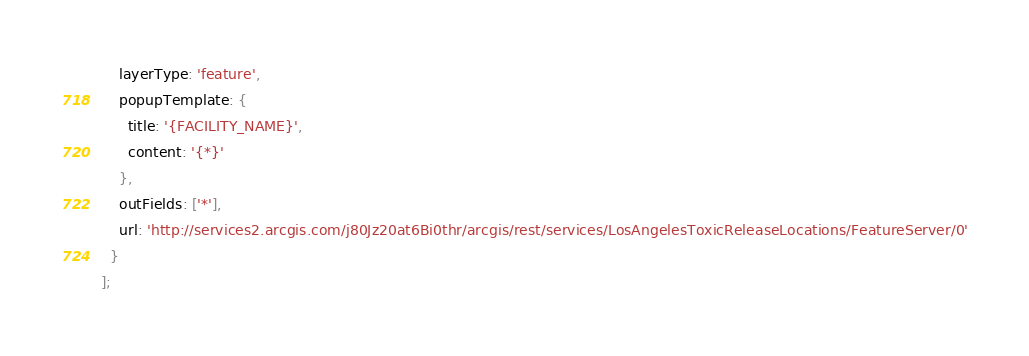<code> <loc_0><loc_0><loc_500><loc_500><_JavaScript_>    layerType: 'feature',
    popupTemplate: {
      title: '{FACILITY_NAME}',
      content: '{*}'
    },
    outFields: ['*'],
    url: 'http://services2.arcgis.com/j80Jz20at6Bi0thr/arcgis/rest/services/LosAngelesToxicReleaseLocations/FeatureServer/0'
  }
];
</code> 